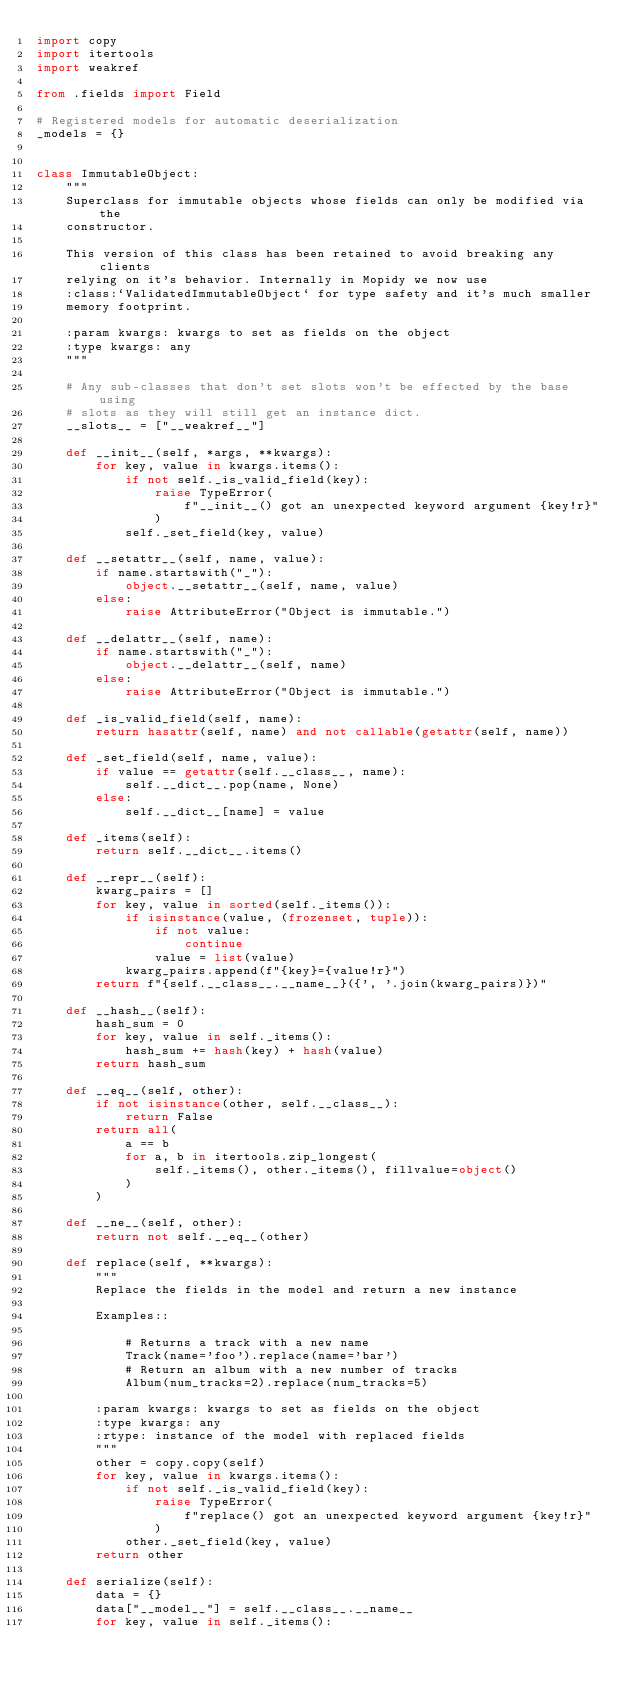Convert code to text. <code><loc_0><loc_0><loc_500><loc_500><_Python_>import copy
import itertools
import weakref

from .fields import Field

# Registered models for automatic deserialization
_models = {}


class ImmutableObject:
    """
    Superclass for immutable objects whose fields can only be modified via the
    constructor.

    This version of this class has been retained to avoid breaking any clients
    relying on it's behavior. Internally in Mopidy we now use
    :class:`ValidatedImmutableObject` for type safety and it's much smaller
    memory footprint.

    :param kwargs: kwargs to set as fields on the object
    :type kwargs: any
    """

    # Any sub-classes that don't set slots won't be effected by the base using
    # slots as they will still get an instance dict.
    __slots__ = ["__weakref__"]

    def __init__(self, *args, **kwargs):
        for key, value in kwargs.items():
            if not self._is_valid_field(key):
                raise TypeError(
                    f"__init__() got an unexpected keyword argument {key!r}"
                )
            self._set_field(key, value)

    def __setattr__(self, name, value):
        if name.startswith("_"):
            object.__setattr__(self, name, value)
        else:
            raise AttributeError("Object is immutable.")

    def __delattr__(self, name):
        if name.startswith("_"):
            object.__delattr__(self, name)
        else:
            raise AttributeError("Object is immutable.")

    def _is_valid_field(self, name):
        return hasattr(self, name) and not callable(getattr(self, name))

    def _set_field(self, name, value):
        if value == getattr(self.__class__, name):
            self.__dict__.pop(name, None)
        else:
            self.__dict__[name] = value

    def _items(self):
        return self.__dict__.items()

    def __repr__(self):
        kwarg_pairs = []
        for key, value in sorted(self._items()):
            if isinstance(value, (frozenset, tuple)):
                if not value:
                    continue
                value = list(value)
            kwarg_pairs.append(f"{key}={value!r}")
        return f"{self.__class__.__name__}({', '.join(kwarg_pairs)})"

    def __hash__(self):
        hash_sum = 0
        for key, value in self._items():
            hash_sum += hash(key) + hash(value)
        return hash_sum

    def __eq__(self, other):
        if not isinstance(other, self.__class__):
            return False
        return all(
            a == b
            for a, b in itertools.zip_longest(
                self._items(), other._items(), fillvalue=object()
            )
        )

    def __ne__(self, other):
        return not self.__eq__(other)

    def replace(self, **kwargs):
        """
        Replace the fields in the model and return a new instance

        Examples::

            # Returns a track with a new name
            Track(name='foo').replace(name='bar')
            # Return an album with a new number of tracks
            Album(num_tracks=2).replace(num_tracks=5)

        :param kwargs: kwargs to set as fields on the object
        :type kwargs: any
        :rtype: instance of the model with replaced fields
        """
        other = copy.copy(self)
        for key, value in kwargs.items():
            if not self._is_valid_field(key):
                raise TypeError(
                    f"replace() got an unexpected keyword argument {key!r}"
                )
            other._set_field(key, value)
        return other

    def serialize(self):
        data = {}
        data["__model__"] = self.__class__.__name__
        for key, value in self._items():</code> 